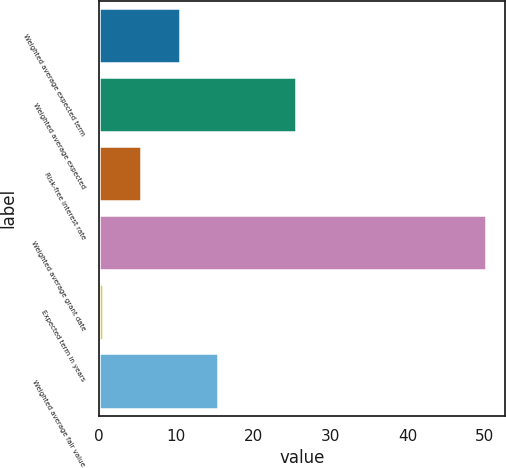Convert chart. <chart><loc_0><loc_0><loc_500><loc_500><bar_chart><fcel>Weighted average expected term<fcel>Weighted average expected<fcel>Risk-free interest rate<fcel>Weighted average grant date<fcel>Expected term in years<fcel>Weighted average fair value<nl><fcel>10.43<fcel>25.6<fcel>5.46<fcel>50.15<fcel>0.5<fcel>15.39<nl></chart> 